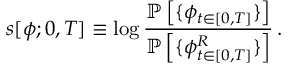<formula> <loc_0><loc_0><loc_500><loc_500>{ s } [ { \phi } ; 0 , T ] \equiv \log \frac { \mathbb { P } \left [ \{ { \phi } _ { t \in [ 0 , T ] } \} \right ] } { \mathbb { P } \left [ \{ { \phi } _ { t \in [ 0 , T ] } ^ { R } \} \right ] } \, .</formula> 